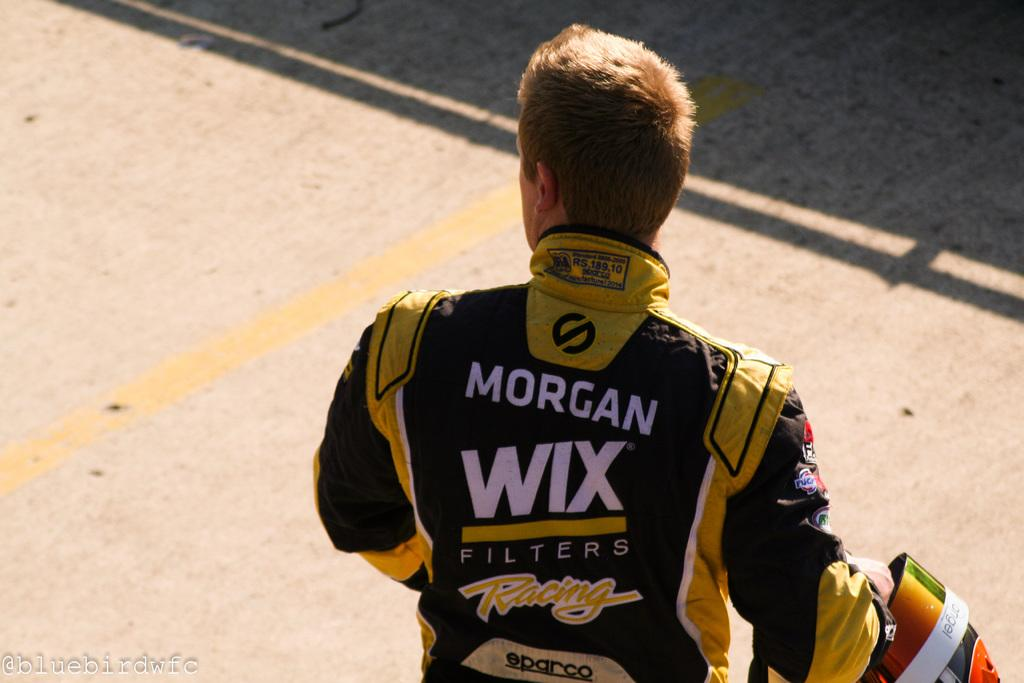<image>
Summarize the visual content of the image. A man's jacket says Morgan WIX on the back. 